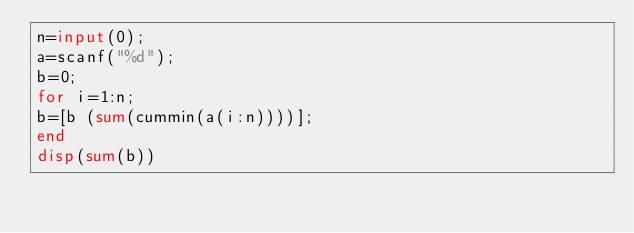Convert code to text. <code><loc_0><loc_0><loc_500><loc_500><_Octave_>n=input(0);
a=scanf("%d");
b=0;
for i=1:n;
b=[b (sum(cummin(a(i:n))))];
end
disp(sum(b))</code> 